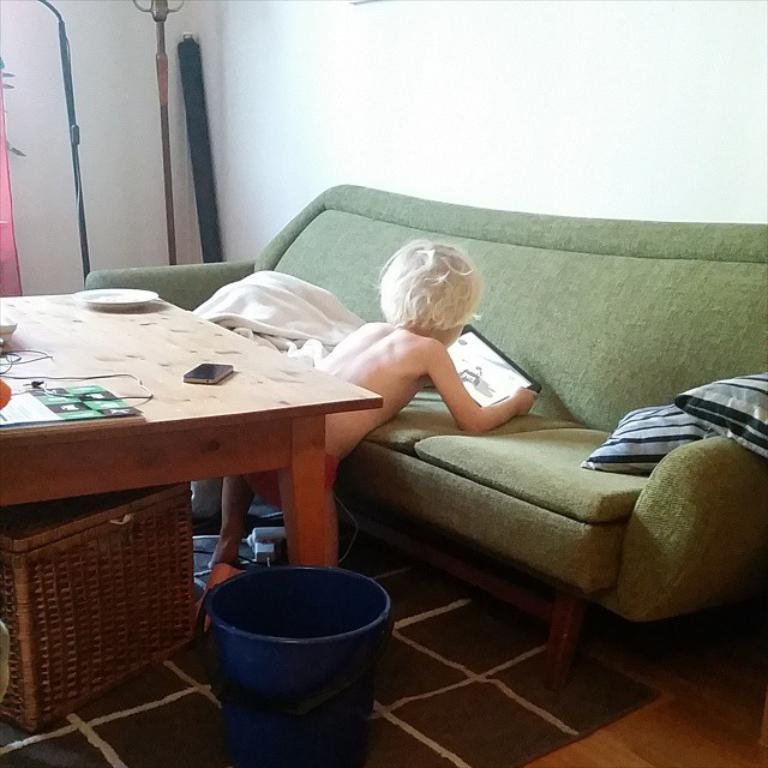What is the person in the image holding? The person in the image is holding a phone. What type of furniture is present in the image? There is a sofa in the image, and it has cushions on it. What other objects can be seen on the sofa? There are no other objects visible on the sofa. What is located next to the sofa? There is a table in the image. What is on the table? There is another phone and plates on the table. What type of payment method is being used for the list in the image? There is no list or payment method present in the image. 